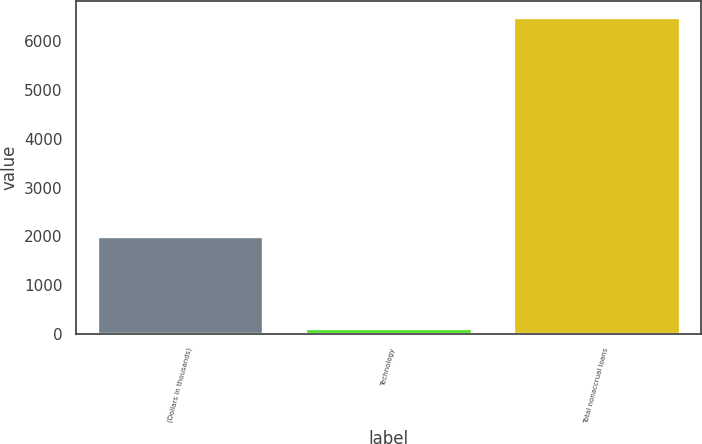Convert chart. <chart><loc_0><loc_0><loc_500><loc_500><bar_chart><fcel>(Dollars in thousands)<fcel>Technology<fcel>Total nonaccrual loans<nl><fcel>2005<fcel>127<fcel>6499<nl></chart> 